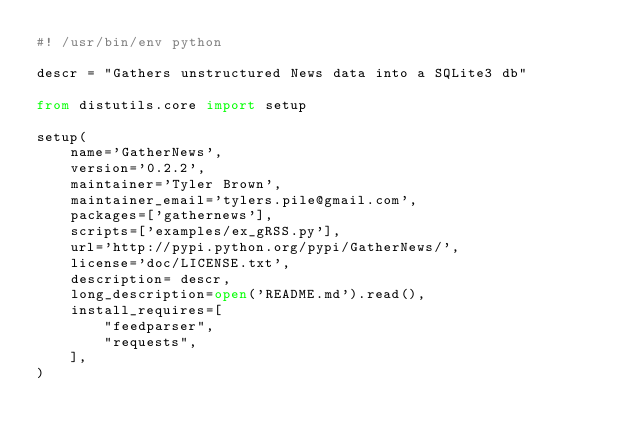Convert code to text. <code><loc_0><loc_0><loc_500><loc_500><_Python_>#! /usr/bin/env python

descr = "Gathers unstructured News data into a SQLite3 db"

from distutils.core import setup

setup(
    name='GatherNews',
    version='0.2.2',
    maintainer='Tyler Brown',
    maintainer_email='tylers.pile@gmail.com',
    packages=['gathernews'],
    scripts=['examples/ex_gRSS.py'],
    url='http://pypi.python.org/pypi/GatherNews/',
    license='doc/LICENSE.txt',
    description= descr,
    long_description=open('README.md').read(),
    install_requires=[
        "feedparser",
        "requests",
    ],
)
</code> 